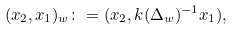<formula> <loc_0><loc_0><loc_500><loc_500>( x _ { 2 } , x _ { 1 } ) _ { w } \colon = ( x _ { 2 } , k ( \Delta _ { w } ) ^ { - 1 } x _ { 1 } ) ,</formula> 